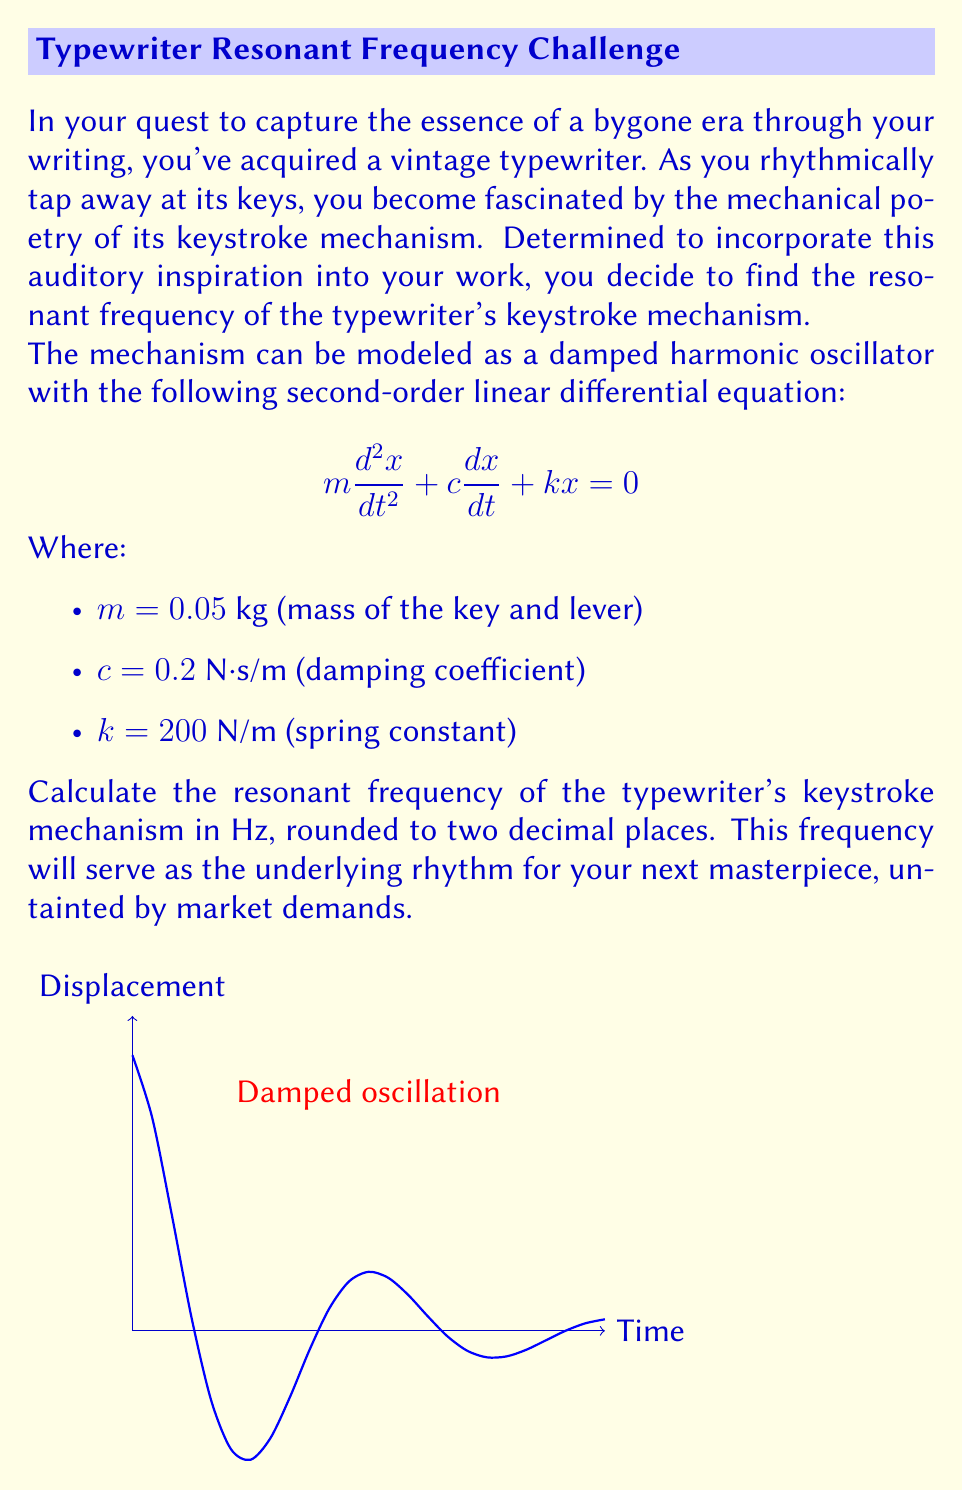Give your solution to this math problem. To find the resonant frequency of the damped harmonic oscillator, we'll follow these steps:

1) The resonant frequency for a damped system is given by:

   $$f_r = \frac{1}{2\pi}\sqrt{\frac{k}{m} - \frac{c^2}{4m^2}}$$

2) We have the following values:
   $m = 0.05$ kg
   $c = 0.2$ N⋅s/m
   $k = 200$ N/m

3) Let's substitute these values into the equation:

   $$f_r = \frac{1}{2\pi}\sqrt{\frac{200}{0.05} - \frac{0.2^2}{4(0.05)^2}}$$

4) Simplify inside the square root:

   $$f_r = \frac{1}{2\pi}\sqrt{4000 - 4}$$

5) Calculate:

   $$f_r = \frac{1}{2\pi}\sqrt{3996}$$
   
   $$f_r = \frac{1}{2\pi} \cdot 63.2138$$
   
   $$f_r = 10.0618$$ Hz

6) Rounding to two decimal places:

   $$f_r \approx 10.06$$ Hz

This resonant frequency represents the natural oscillation of the typewriter's keystroke mechanism, uninfluenced by external market forces, just as your writing remains true to your artistic vision.
Answer: 10.06 Hz 